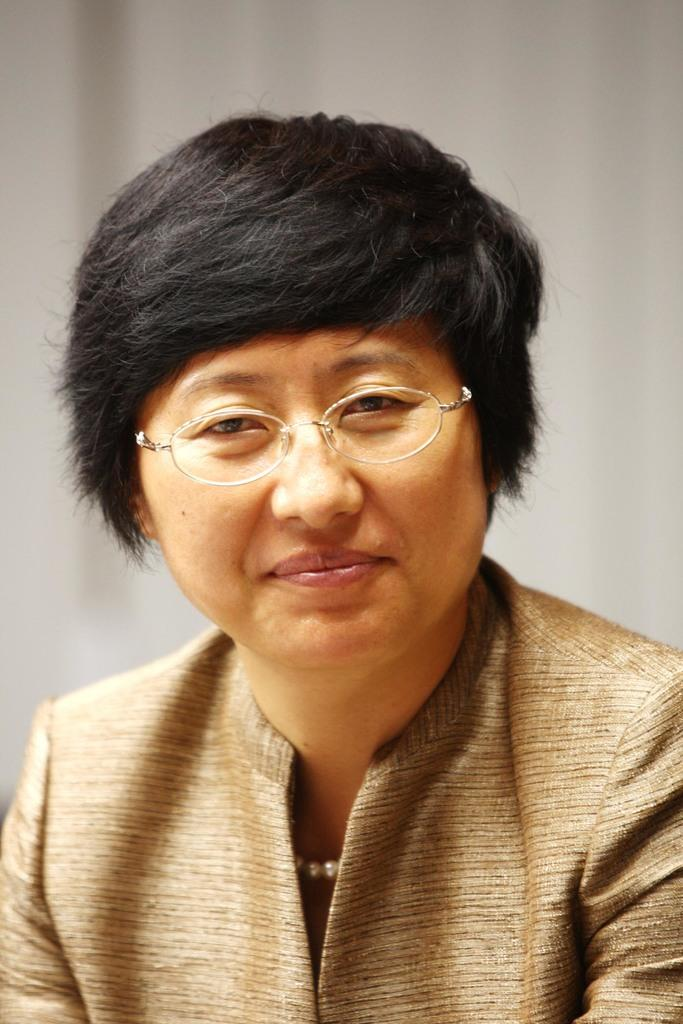Who or what is the main subject in the image? There is a person in the image. Can you describe the person's attire? The person is wearing clothes. What accessory is the person wearing on their face? The person is wearing spectacles. What type of spoon is the person holding in the image? There is no spoon present in the image. What kind of shoes is the person wearing in the image? The provided facts do not mention shoes, so we cannot determine the type of shoes the person is wearing in the image. 